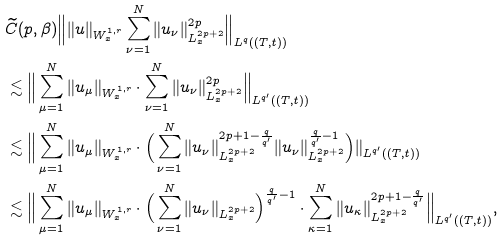Convert formula to latex. <formula><loc_0><loc_0><loc_500><loc_500>& \widetilde { C } ( p , \beta ) \Big \| \| u \| _ { W ^ { 1 , r } _ { x } } \sum _ { \nu = 1 } ^ { N } \| u _ { \nu } \| _ { L _ { x } ^ { 2 p + 2 } } ^ { 2 p } \Big \| _ { L ^ { q } ( ( T , t ) ) } \\ & \lesssim \Big \| \sum _ { \mu = 1 } ^ { N } \| u _ { \mu } \| _ { W ^ { 1 , r } _ { x } } \cdot \sum _ { \nu = 1 } ^ { N } \| u _ { \nu } \| _ { L _ { x } ^ { 2 p + 2 } } ^ { 2 p } \Big \| _ { L ^ { q ^ { \prime } } ( ( T , t ) ) } \\ & \lesssim \Big \| \sum _ { \mu = 1 } ^ { N } \| u _ { \mu } \| _ { W ^ { 1 , r } _ { x } } \cdot \Big ( \sum _ { \nu = 1 } ^ { N } \| u _ { \nu } \| _ { L _ { x } ^ { 2 p + 2 } } ^ { 2 p + 1 - \frac { q } { q ^ { \prime } } } \| u _ { \nu } \| _ { L _ { x } ^ { 2 p + 2 } } ^ { \frac { q } { q ^ { \prime } } - 1 } \Big ) \| _ { L ^ { q ^ { \prime } } ( ( T , t ) ) } \\ & \lesssim \Big \| \sum _ { \mu = 1 } ^ { N } \| u _ { \mu } \| _ { W ^ { 1 , r } _ { x } } \cdot \Big ( \sum _ { \nu = 1 } ^ { N } \| u _ { \nu } \| _ { L _ { x } ^ { 2 p + 2 } } \Big ) ^ { \frac { q } { q ^ { \prime } } - 1 } \cdot \sum _ { \kappa = 1 } ^ { N } \| u _ { \kappa } \| _ { L _ { x } ^ { 2 p + 2 } } ^ { 2 p + 1 - \frac { q } { q ^ { \prime } } } \Big \| _ { L ^ { q ^ { \prime } } ( ( T , t ) ) } ,</formula> 